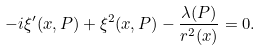Convert formula to latex. <formula><loc_0><loc_0><loc_500><loc_500>- i \xi ^ { \prime } ( x , P ) + \xi ^ { 2 } ( x , P ) - \frac { \lambda ( P ) } { r ^ { 2 } ( x ) } = 0 .</formula> 